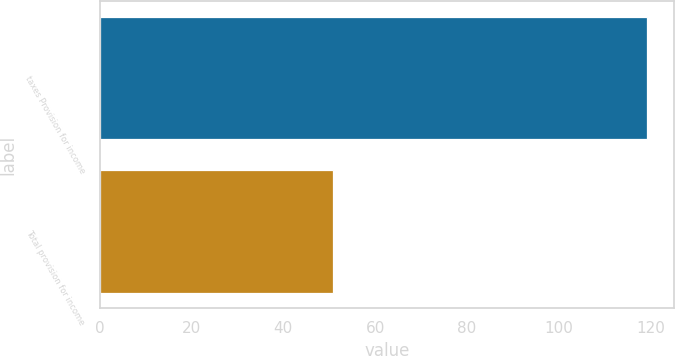<chart> <loc_0><loc_0><loc_500><loc_500><bar_chart><fcel>taxes Provision for income<fcel>Total provision for income<nl><fcel>119.2<fcel>50.9<nl></chart> 